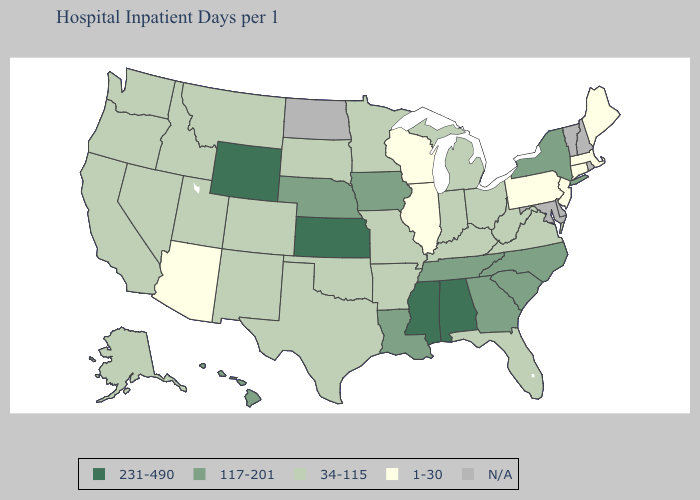What is the value of Oklahoma?
Write a very short answer. 34-115. Does Louisiana have the highest value in the USA?
Keep it brief. No. What is the value of Kansas?
Give a very brief answer. 231-490. Does New York have the highest value in the Northeast?
Keep it brief. Yes. What is the value of Connecticut?
Write a very short answer. 1-30. What is the highest value in the USA?
Answer briefly. 231-490. What is the value of Florida?
Keep it brief. 34-115. Is the legend a continuous bar?
Give a very brief answer. No. Which states hav the highest value in the MidWest?
Be succinct. Kansas. Does Mississippi have the highest value in the USA?
Give a very brief answer. Yes. Name the states that have a value in the range 117-201?
Write a very short answer. Georgia, Hawaii, Iowa, Louisiana, Nebraska, New York, North Carolina, South Carolina, Tennessee. What is the lowest value in the USA?
Short answer required. 1-30. Name the states that have a value in the range 1-30?
Concise answer only. Arizona, Connecticut, Illinois, Maine, Massachusetts, New Jersey, Pennsylvania, Wisconsin. Among the states that border Wyoming , which have the lowest value?
Answer briefly. Colorado, Idaho, Montana, South Dakota, Utah. 